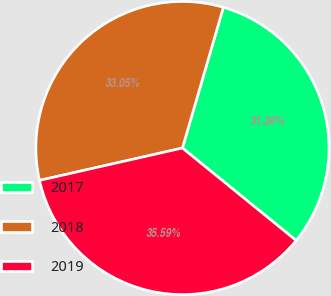<chart> <loc_0><loc_0><loc_500><loc_500><pie_chart><fcel>2017<fcel>2018<fcel>2019<nl><fcel>31.36%<fcel>33.05%<fcel>35.59%<nl></chart> 